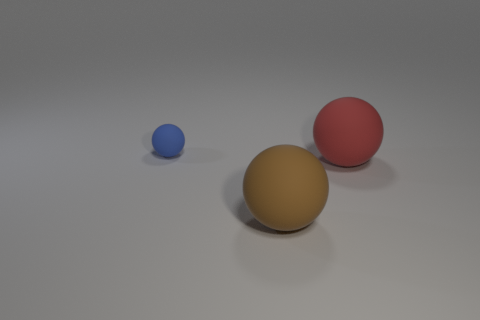Is there anything else that is the same size as the blue ball?
Offer a terse response. No. There is another big thing that is the same shape as the large brown matte thing; what material is it?
Provide a succinct answer. Rubber. Is the shape of the large brown object the same as the blue rubber object?
Make the answer very short. Yes. There is a brown thing; what number of big balls are behind it?
Keep it short and to the point. 1. There is a large rubber object in front of the big matte thing that is behind the large brown matte ball; what shape is it?
Give a very brief answer. Sphere. Do the rubber ball on the right side of the brown rubber object and the object that is to the left of the big brown thing have the same size?
Provide a succinct answer. No. There is a big matte object left of the large red matte object; what shape is it?
Offer a very short reply. Sphere. What color is the small sphere?
Your response must be concise. Blue. There is a blue matte sphere; is it the same size as the thing right of the brown rubber sphere?
Make the answer very short. No. How many shiny objects are either small objects or large objects?
Offer a terse response. 0. 